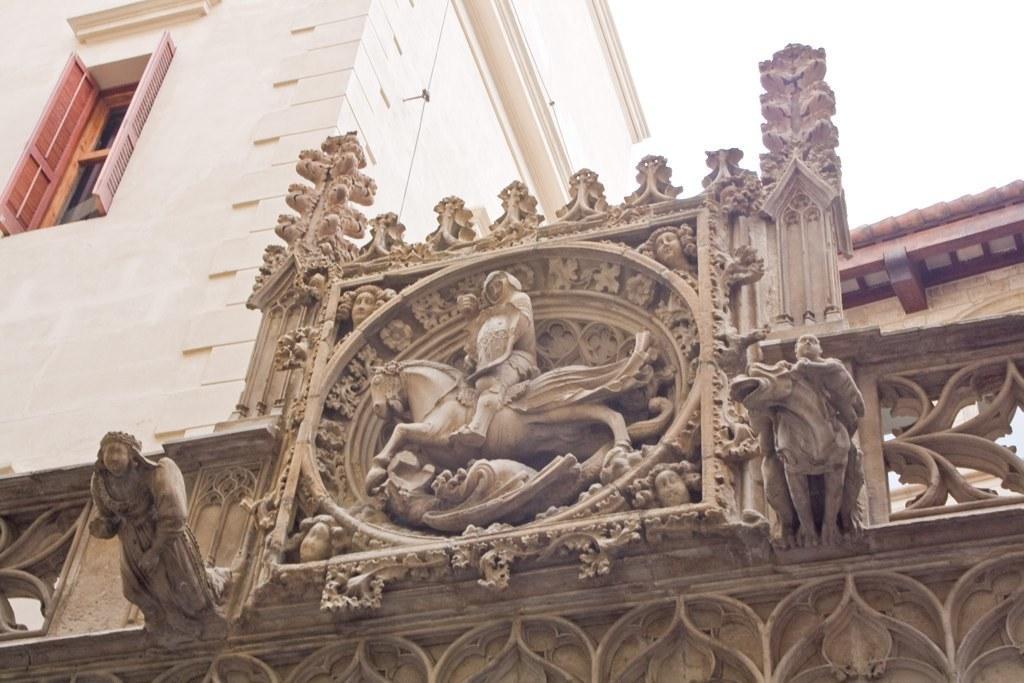Describe this image in one or two sentences. In this image I can see an arch, on the arch I can see few statues, background I can see the building in cream color, sky in white color. 